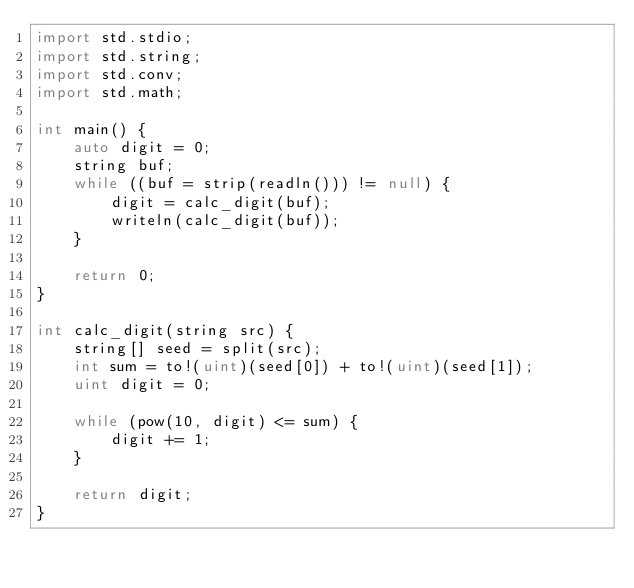<code> <loc_0><loc_0><loc_500><loc_500><_D_>import std.stdio;
import std.string;
import std.conv;
import std.math;

int main() {
    auto digit = 0;
    string buf;
    while ((buf = strip(readln())) != null) {
        digit = calc_digit(buf);
        writeln(calc_digit(buf));
    }

    return 0;
}

int calc_digit(string src) {
    string[] seed = split(src);
    int sum = to!(uint)(seed[0]) + to!(uint)(seed[1]);
    uint digit = 0;

    while (pow(10, digit) <= sum) {
        digit += 1;
    }

    return digit;
}</code> 